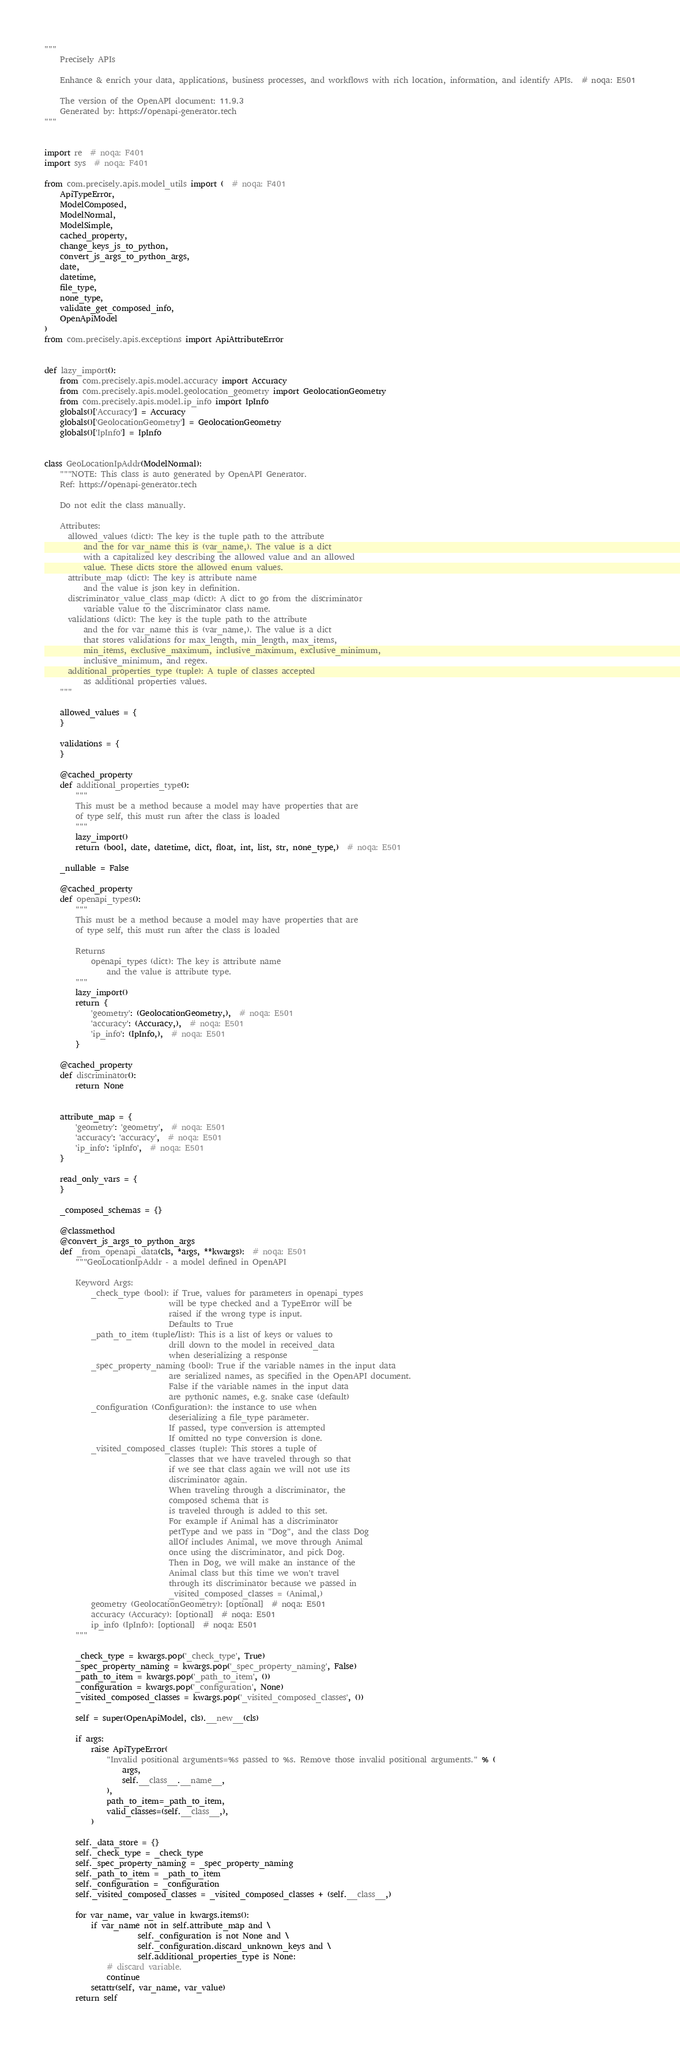Convert code to text. <code><loc_0><loc_0><loc_500><loc_500><_Python_>"""
    Precisely APIs

    Enhance & enrich your data, applications, business processes, and workflows with rich location, information, and identify APIs.  # noqa: E501

    The version of the OpenAPI document: 11.9.3
    Generated by: https://openapi-generator.tech
"""


import re  # noqa: F401
import sys  # noqa: F401

from com.precisely.apis.model_utils import (  # noqa: F401
    ApiTypeError,
    ModelComposed,
    ModelNormal,
    ModelSimple,
    cached_property,
    change_keys_js_to_python,
    convert_js_args_to_python_args,
    date,
    datetime,
    file_type,
    none_type,
    validate_get_composed_info,
    OpenApiModel
)
from com.precisely.apis.exceptions import ApiAttributeError


def lazy_import():
    from com.precisely.apis.model.accuracy import Accuracy
    from com.precisely.apis.model.geolocation_geometry import GeolocationGeometry
    from com.precisely.apis.model.ip_info import IpInfo
    globals()['Accuracy'] = Accuracy
    globals()['GeolocationGeometry'] = GeolocationGeometry
    globals()['IpInfo'] = IpInfo


class GeoLocationIpAddr(ModelNormal):
    """NOTE: This class is auto generated by OpenAPI Generator.
    Ref: https://openapi-generator.tech

    Do not edit the class manually.

    Attributes:
      allowed_values (dict): The key is the tuple path to the attribute
          and the for var_name this is (var_name,). The value is a dict
          with a capitalized key describing the allowed value and an allowed
          value. These dicts store the allowed enum values.
      attribute_map (dict): The key is attribute name
          and the value is json key in definition.
      discriminator_value_class_map (dict): A dict to go from the discriminator
          variable value to the discriminator class name.
      validations (dict): The key is the tuple path to the attribute
          and the for var_name this is (var_name,). The value is a dict
          that stores validations for max_length, min_length, max_items,
          min_items, exclusive_maximum, inclusive_maximum, exclusive_minimum,
          inclusive_minimum, and regex.
      additional_properties_type (tuple): A tuple of classes accepted
          as additional properties values.
    """

    allowed_values = {
    }

    validations = {
    }

    @cached_property
    def additional_properties_type():
        """
        This must be a method because a model may have properties that are
        of type self, this must run after the class is loaded
        """
        lazy_import()
        return (bool, date, datetime, dict, float, int, list, str, none_type,)  # noqa: E501

    _nullable = False

    @cached_property
    def openapi_types():
        """
        This must be a method because a model may have properties that are
        of type self, this must run after the class is loaded

        Returns
            openapi_types (dict): The key is attribute name
                and the value is attribute type.
        """
        lazy_import()
        return {
            'geometry': (GeolocationGeometry,),  # noqa: E501
            'accuracy': (Accuracy,),  # noqa: E501
            'ip_info': (IpInfo,),  # noqa: E501
        }

    @cached_property
    def discriminator():
        return None


    attribute_map = {
        'geometry': 'geometry',  # noqa: E501
        'accuracy': 'accuracy',  # noqa: E501
        'ip_info': 'ipInfo',  # noqa: E501
    }

    read_only_vars = {
    }

    _composed_schemas = {}

    @classmethod
    @convert_js_args_to_python_args
    def _from_openapi_data(cls, *args, **kwargs):  # noqa: E501
        """GeoLocationIpAddr - a model defined in OpenAPI

        Keyword Args:
            _check_type (bool): if True, values for parameters in openapi_types
                                will be type checked and a TypeError will be
                                raised if the wrong type is input.
                                Defaults to True
            _path_to_item (tuple/list): This is a list of keys or values to
                                drill down to the model in received_data
                                when deserializing a response
            _spec_property_naming (bool): True if the variable names in the input data
                                are serialized names, as specified in the OpenAPI document.
                                False if the variable names in the input data
                                are pythonic names, e.g. snake case (default)
            _configuration (Configuration): the instance to use when
                                deserializing a file_type parameter.
                                If passed, type conversion is attempted
                                If omitted no type conversion is done.
            _visited_composed_classes (tuple): This stores a tuple of
                                classes that we have traveled through so that
                                if we see that class again we will not use its
                                discriminator again.
                                When traveling through a discriminator, the
                                composed schema that is
                                is traveled through is added to this set.
                                For example if Animal has a discriminator
                                petType and we pass in "Dog", and the class Dog
                                allOf includes Animal, we move through Animal
                                once using the discriminator, and pick Dog.
                                Then in Dog, we will make an instance of the
                                Animal class but this time we won't travel
                                through its discriminator because we passed in
                                _visited_composed_classes = (Animal,)
            geometry (GeolocationGeometry): [optional]  # noqa: E501
            accuracy (Accuracy): [optional]  # noqa: E501
            ip_info (IpInfo): [optional]  # noqa: E501
        """

        _check_type = kwargs.pop('_check_type', True)
        _spec_property_naming = kwargs.pop('_spec_property_naming', False)
        _path_to_item = kwargs.pop('_path_to_item', ())
        _configuration = kwargs.pop('_configuration', None)
        _visited_composed_classes = kwargs.pop('_visited_composed_classes', ())

        self = super(OpenApiModel, cls).__new__(cls)

        if args:
            raise ApiTypeError(
                "Invalid positional arguments=%s passed to %s. Remove those invalid positional arguments." % (
                    args,
                    self.__class__.__name__,
                ),
                path_to_item=_path_to_item,
                valid_classes=(self.__class__,),
            )

        self._data_store = {}
        self._check_type = _check_type
        self._spec_property_naming = _spec_property_naming
        self._path_to_item = _path_to_item
        self._configuration = _configuration
        self._visited_composed_classes = _visited_composed_classes + (self.__class__,)

        for var_name, var_value in kwargs.items():
            if var_name not in self.attribute_map and \
                        self._configuration is not None and \
                        self._configuration.discard_unknown_keys and \
                        self.additional_properties_type is None:
                # discard variable.
                continue
            setattr(self, var_name, var_value)
        return self
</code> 